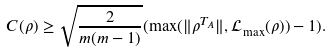<formula> <loc_0><loc_0><loc_500><loc_500>C ( \rho ) \geq \sqrt { \frac { 2 } { m ( m - 1 ) } } ( \max ( \| \rho ^ { T _ { A } } \| , \mathcal { L } _ { \max } ( \rho ) ) - 1 ) .</formula> 